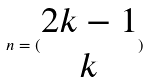<formula> <loc_0><loc_0><loc_500><loc_500>n = ( \begin{matrix} 2 k - 1 \\ k \end{matrix} )</formula> 